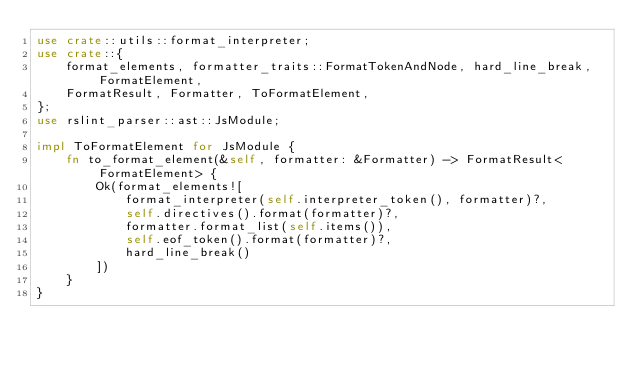<code> <loc_0><loc_0><loc_500><loc_500><_Rust_>use crate::utils::format_interpreter;
use crate::{
    format_elements, formatter_traits::FormatTokenAndNode, hard_line_break, FormatElement,
    FormatResult, Formatter, ToFormatElement,
};
use rslint_parser::ast::JsModule;

impl ToFormatElement for JsModule {
    fn to_format_element(&self, formatter: &Formatter) -> FormatResult<FormatElement> {
        Ok(format_elements![
            format_interpreter(self.interpreter_token(), formatter)?,
            self.directives().format(formatter)?,
            formatter.format_list(self.items()),
            self.eof_token().format(formatter)?,
            hard_line_break()
        ])
    }
}
</code> 